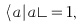Convert formula to latex. <formula><loc_0><loc_0><loc_500><loc_500>\langle a | a \rangle = 1 ,</formula> 